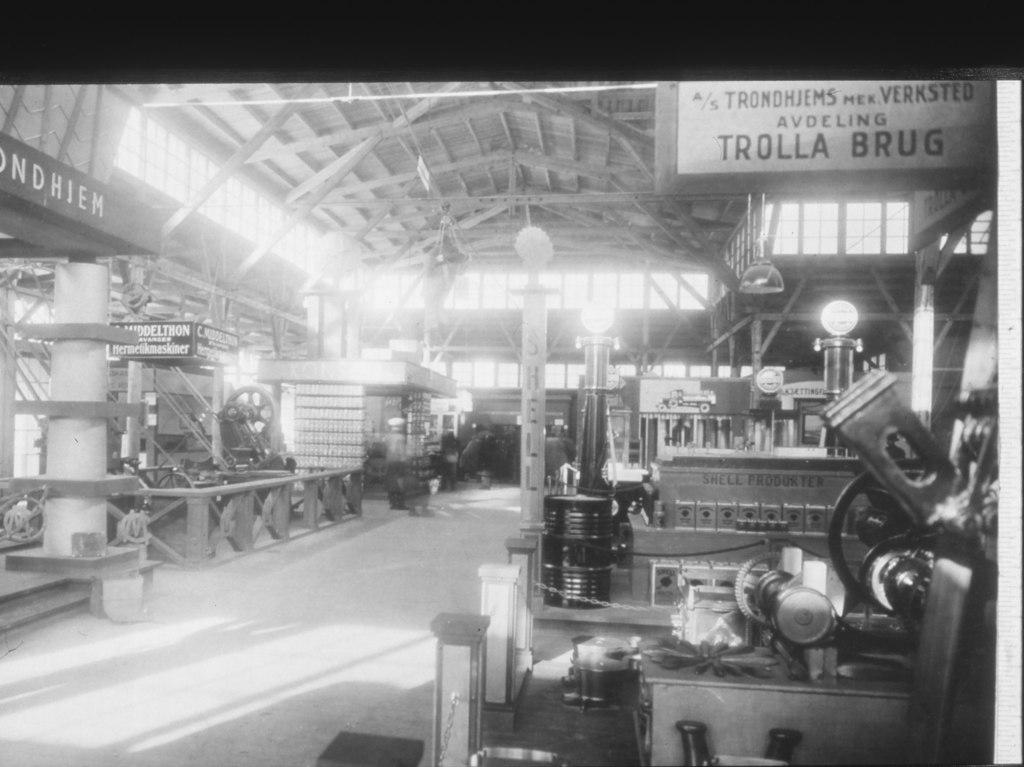What is the color scheme of the image? The image is black and white. What types of objects can be seen in the image? There are machines, lights, chains, boards, and other objects in the image. What is the floor like in the image? There is a floor at the bottom of the image. What is the roof like in the image? There is a roof at the top of the image. What letter is being played on the piano in the image? There is no piano present in the image, so it is not possible to determine what letter might be played. 